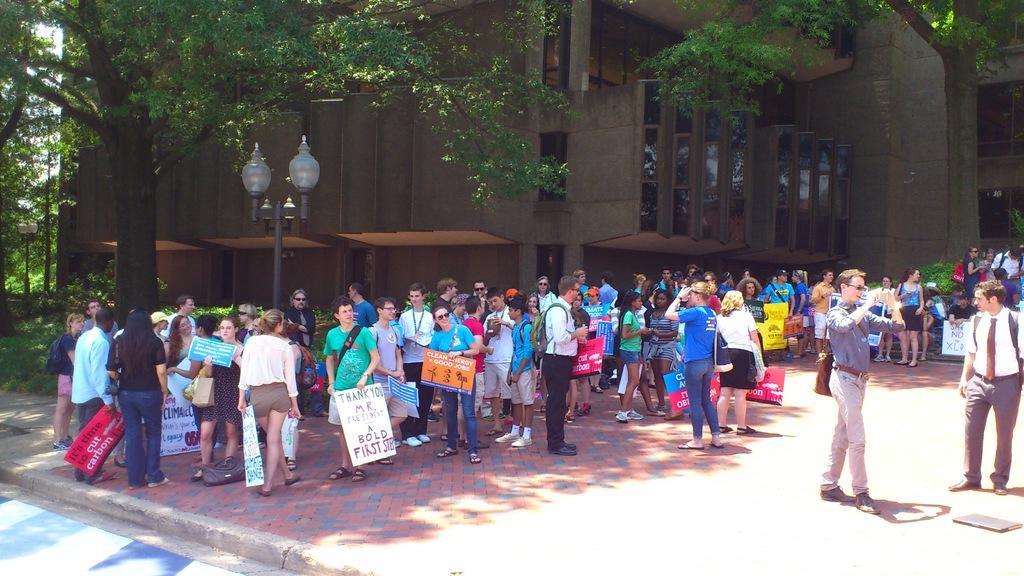Please provide a concise description of this image. There is a crowd. Some are holding placards. There is a light pole. Also there are trees. In the back there is a building with glass windows. 